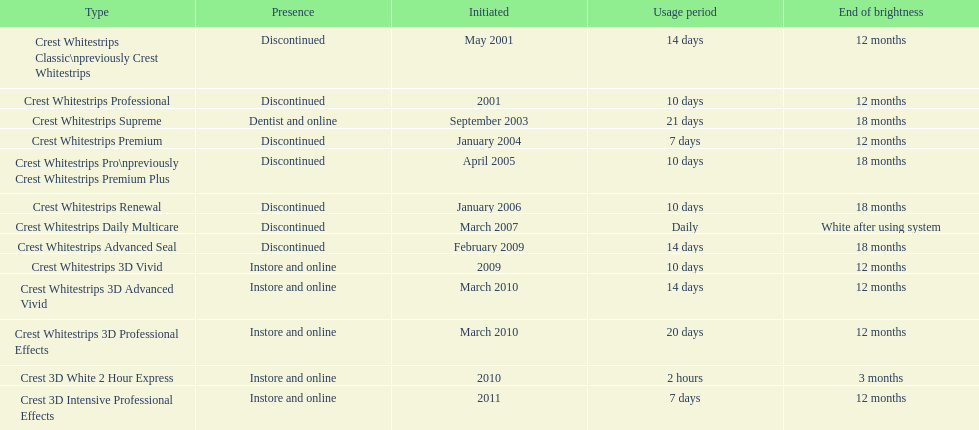Tell me the number of products that give you 12 months of whiteness. 7. 